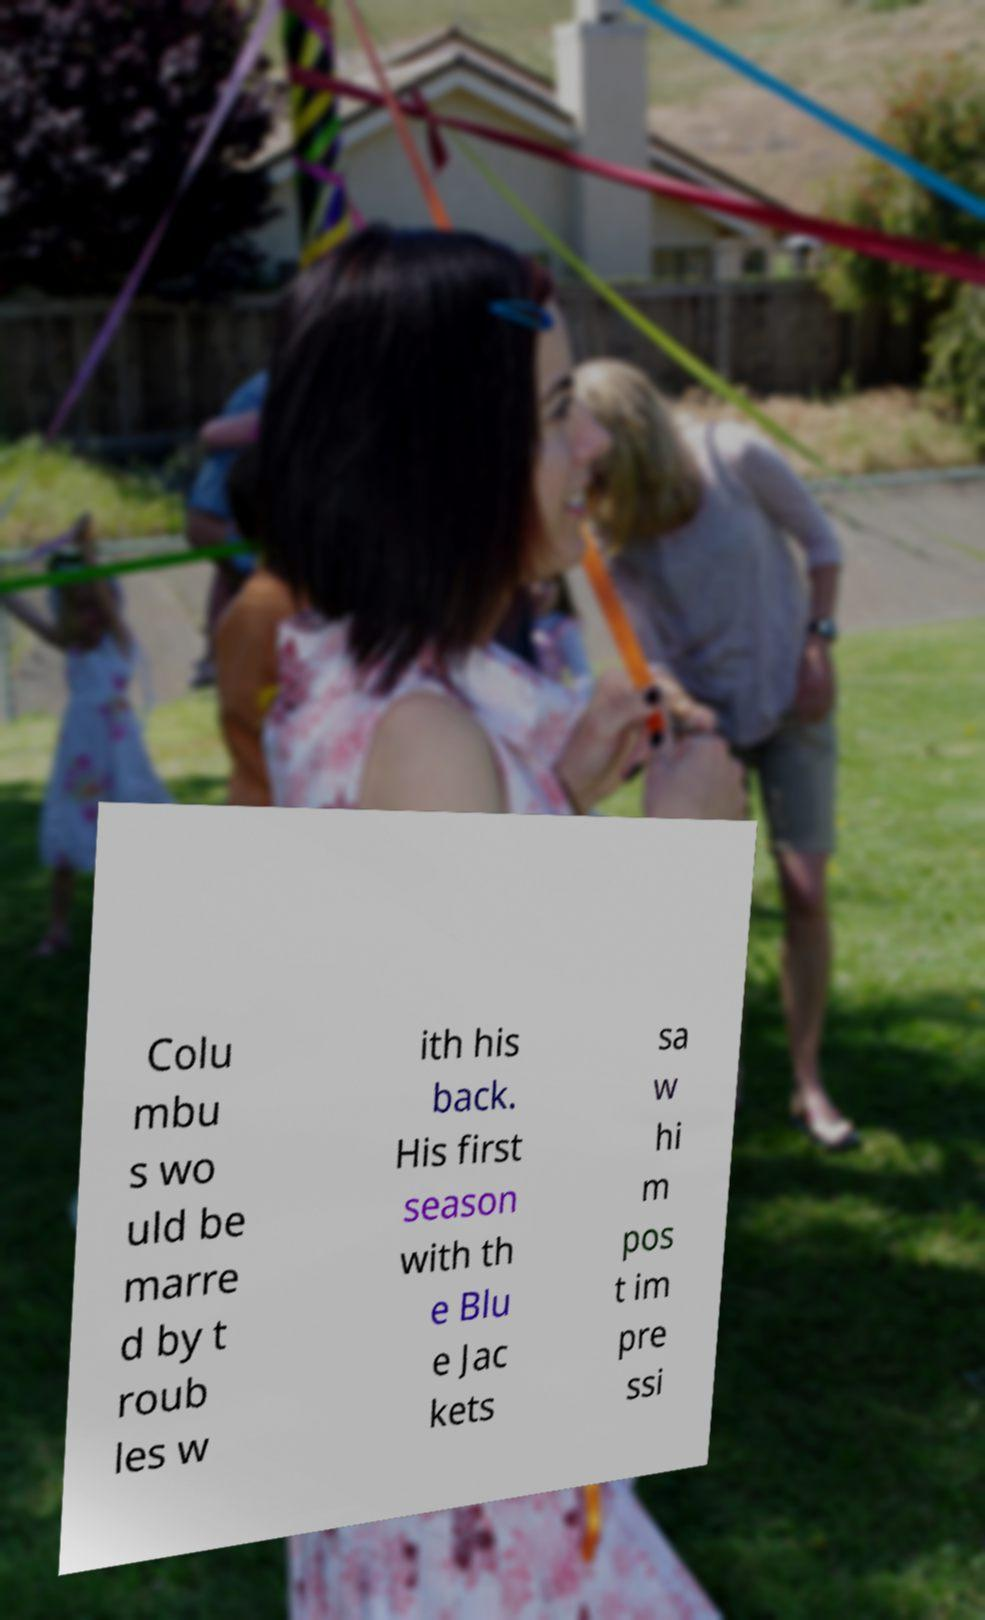I need the written content from this picture converted into text. Can you do that? Colu mbu s wo uld be marre d by t roub les w ith his back. His first season with th e Blu e Jac kets sa w hi m pos t im pre ssi 